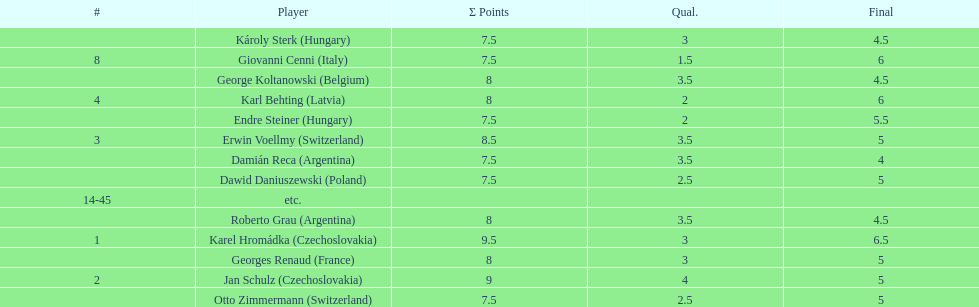I'm looking to parse the entire table for insights. Could you assist me with that? {'header': ['#', 'Player', 'Σ Points', 'Qual.', 'Final'], 'rows': [['', 'Károly Sterk\xa0(Hungary)', '7.5', '3', '4.5'], ['8', 'Giovanni Cenni\xa0(Italy)', '7.5', '1.5', '6'], ['', 'George Koltanowski\xa0(Belgium)', '8', '3.5', '4.5'], ['4', 'Karl Behting\xa0(Latvia)', '8', '2', '6'], ['', 'Endre Steiner\xa0(Hungary)', '7.5', '2', '5.5'], ['3', 'Erwin Voellmy\xa0(Switzerland)', '8.5', '3.5', '5'], ['', 'Damián Reca\xa0(Argentina)', '7.5', '3.5', '4'], ['', 'Dawid Daniuszewski\xa0(Poland)', '7.5', '2.5', '5'], ['14-45', 'etc.', '', '', ''], ['', 'Roberto Grau\xa0(Argentina)', '8', '3.5', '4.5'], ['1', 'Karel Hromádka\xa0(Czechoslovakia)', '9.5', '3', '6.5'], ['', 'Georges Renaud\xa0(France)', '8', '3', '5'], ['2', 'Jan Schulz\xa0(Czechoslovakia)', '9', '4', '5'], ['', 'Otto Zimmermann\xa0(Switzerland)', '7.5', '2.5', '5']]} The most points were scored by which player? Karel Hromádka. 